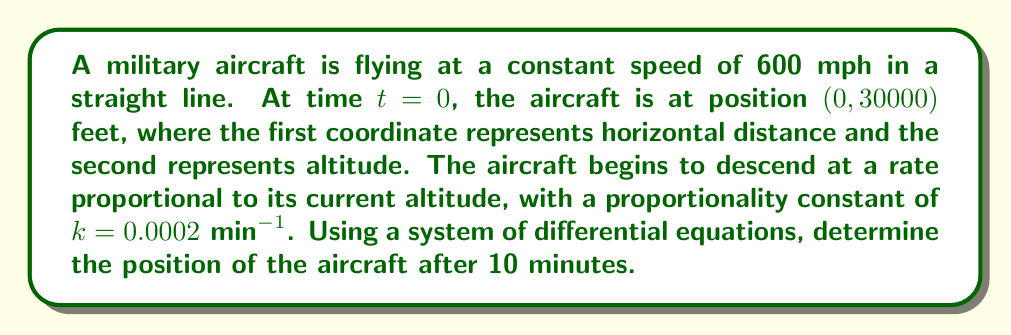Could you help me with this problem? Let's approach this step-by-step:

1) Let x(t) represent the horizontal distance and y(t) represent the altitude at time t.

2) We can set up a system of differential equations:

   $$\frac{dx}{dt} = 600 \cdot \frac{5280}{60} = 52800$$ (feet per minute)
   $$\frac{dy}{dt} = -0.0002y$$

3) The initial conditions are:
   x(0) = 0
   y(0) = 30000

4) For the x-coordinate, we can integrate directly:
   $$x(t) = 52800t + C$$
   Using the initial condition, we get C = 0, so:
   $$x(t) = 52800t$$

5) For the y-coordinate, we have a separable differential equation:
   $$\frac{dy}{y} = -0.0002dt$$

6) Integrating both sides:
   $$\ln|y| = -0.0002t + C$$

7) Using the initial condition y(0) = 30000:
   $$\ln(30000) = C$$

8) Therefore, the solution for y is:
   $$y(t) = 30000e^{-0.0002t}$$

9) After 10 minutes, the position is:
   x(10) = 52800 * 10 = 528000 feet
   y(10) = 30000 * e^(-0.0002 * 10) ≈ 29940.12 feet

Therefore, after 10 minutes, the aircraft's position is approximately (528000, 29940.12) feet.
Answer: (528000, 29940.12) feet 